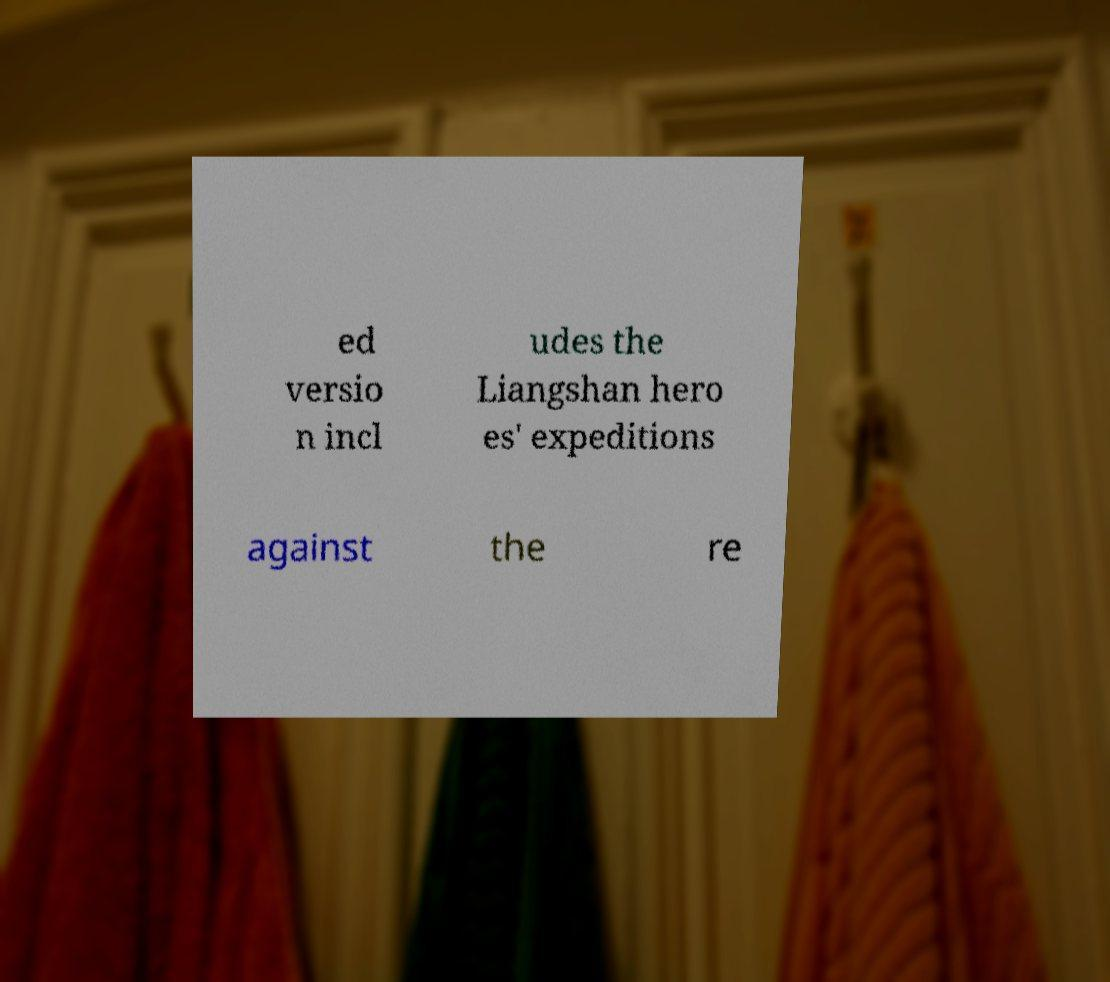There's text embedded in this image that I need extracted. Can you transcribe it verbatim? ed versio n incl udes the Liangshan hero es' expeditions against the re 